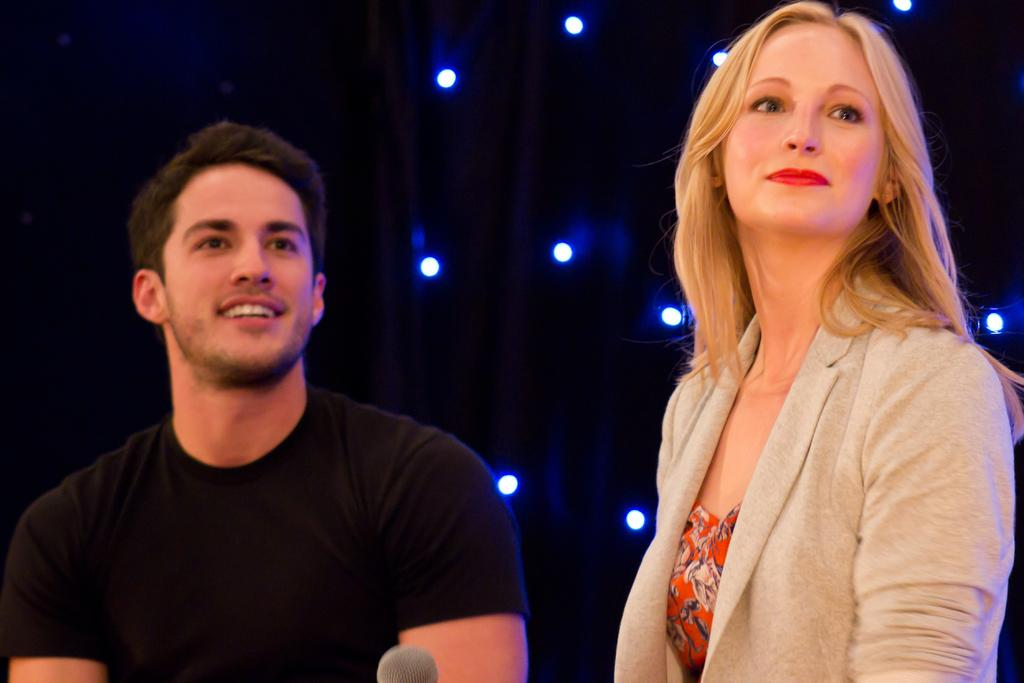What is the man in the image wearing? The man is wearing a black T-shirt. What is the woman in the image wearing? The woman is wearing an orange dress and a cream-colored coat. Can you describe the background of the image? There are lights visible in the background of the image. How many cherries are on the ghost's head in the image? There is no ghost or cherries present in the image. 